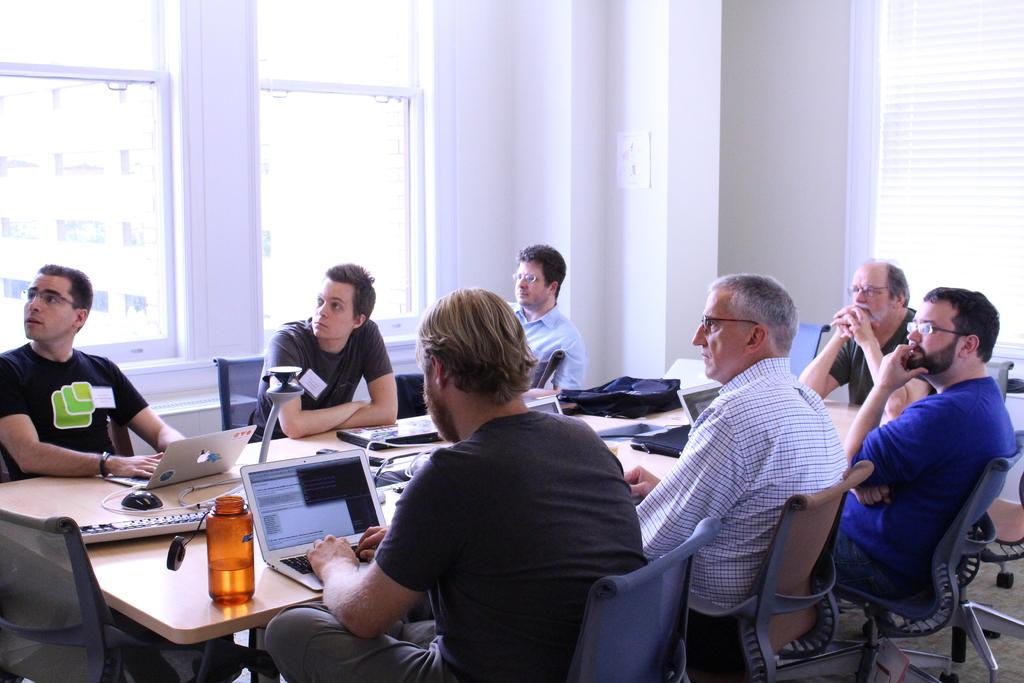What is happening in the image? There is a group of people in the image, and they are sitting around a table. What are the people doing while sitting around the table? The people are operating laptops. What type of bean is present on the throne in the image? There is no bean or throne present in the image; it features a group of people sitting around a table and operating laptops. 